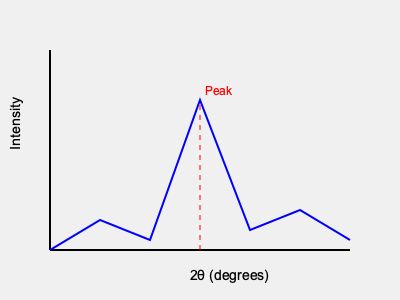Based on the X-ray diffraction pattern shown, calculate the interplanar spacing $(d)$ of the crystal planes responsible for the most intense peak, given that the X-ray wavelength $(\lambda)$ used is 1.54 Å and the peak occurs at a $2\theta$ angle of 22.5°. Use Bragg's Law: $n\lambda = 2d\sin\theta$, where $n=1$ for the first-order diffraction. To solve this problem, we'll follow these steps:

1. Identify the given information:
   - X-ray wavelength $(\lambda) = 1.54$ Å
   - $2\theta$ angle of the most intense peak $= 22.5°$
   - $n = 1$ (first-order diffraction)

2. Convert the $2\theta$ angle to $\theta$:
   $\theta = 22.5° \div 2 = 11.25°$

3. Apply Bragg's Law: $n\lambda = 2d\sin\theta$
   Rearrange the equation to solve for $d$:
   $d = \frac{n\lambda}{2\sin\theta}$

4. Convert $\theta$ to radians:
   $11.25° \times \frac{\pi}{180°} = 0.1963$ radians

5. Substitute the values into the equation:
   $d = \frac{1 \times 1.54\text{ Å}}{2\sin(0.1963)}$

6. Calculate the result:
   $d = \frac{1.54\text{ Å}}{2 \times 0.1951} = 3.95$ Å

Therefore, the interplanar spacing $(d)$ of the crystal planes responsible for the most intense peak is 3.95 Å.
Answer: 3.95 Å 